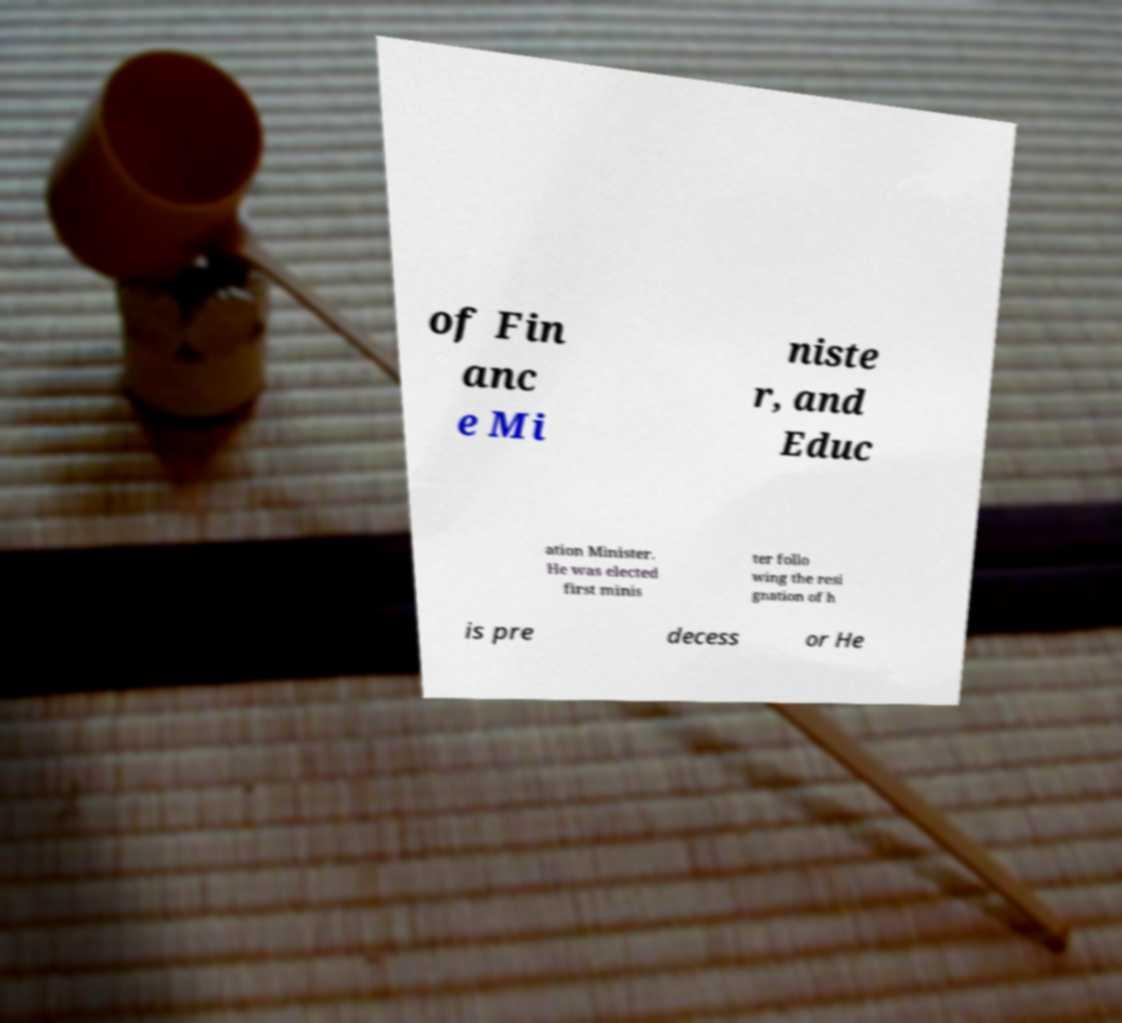Can you accurately transcribe the text from the provided image for me? of Fin anc e Mi niste r, and Educ ation Minister. He was elected first minis ter follo wing the resi gnation of h is pre decess or He 